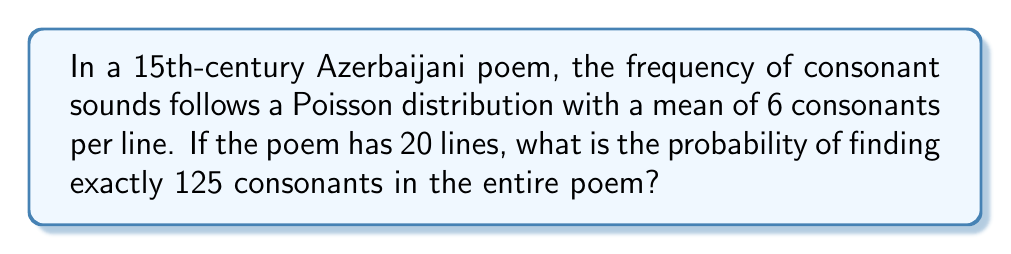Can you answer this question? To solve this problem, we need to use the Poisson distribution formula and apply it to the entire poem. Let's break it down step-by-step:

1. The Poisson distribution formula is:

   $$P(X = k) = \frac{e^{-\lambda} \lambda^k}{k!}$$

   where $\lambda$ is the mean and $k$ is the number of occurrences.

2. In this case, we have:
   - $\lambda = 6$ consonants per line
   - 20 lines in the poem
   - We want to find $P(X = 125)$ for the entire poem

3. First, we need to calculate the mean for the entire poem:
   $$\lambda_{total} = 6 \times 20 = 120$$

4. Now we can apply the Poisson formula:

   $$P(X = 125) = \frac{e^{-120} 120^{125}}{125!}$$

5. This can be calculated using a scientific calculator or computer software:

   $$P(X = 125) \approx 0.0318$$

Thus, the probability of finding exactly 125 consonants in the entire poem is approximately 0.0318 or 3.18%.
Answer: 0.0318 (or 3.18%) 